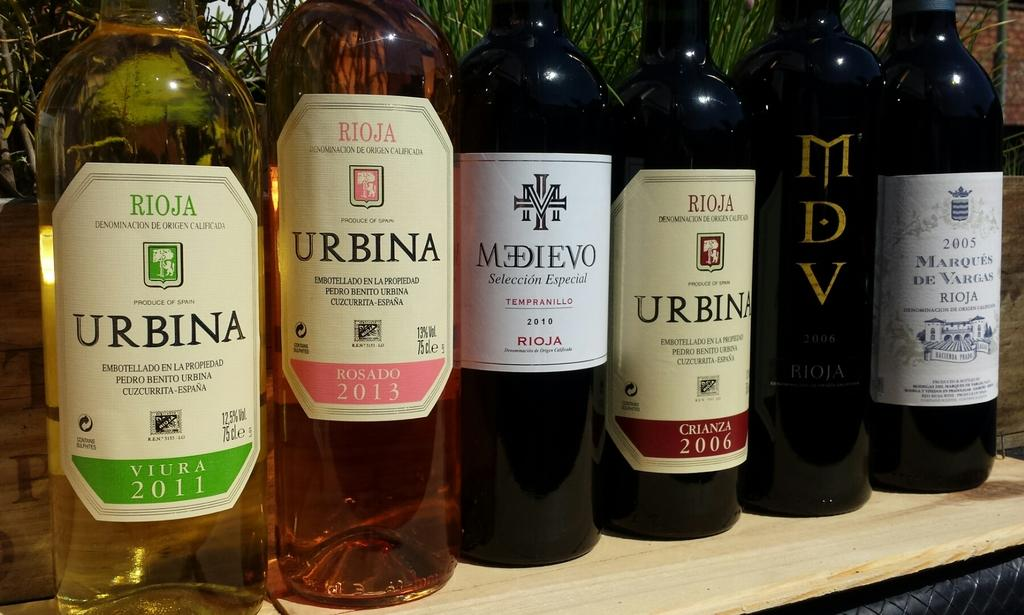<image>
Share a concise interpretation of the image provided. Six bottles of wine of which three are Urbina. 